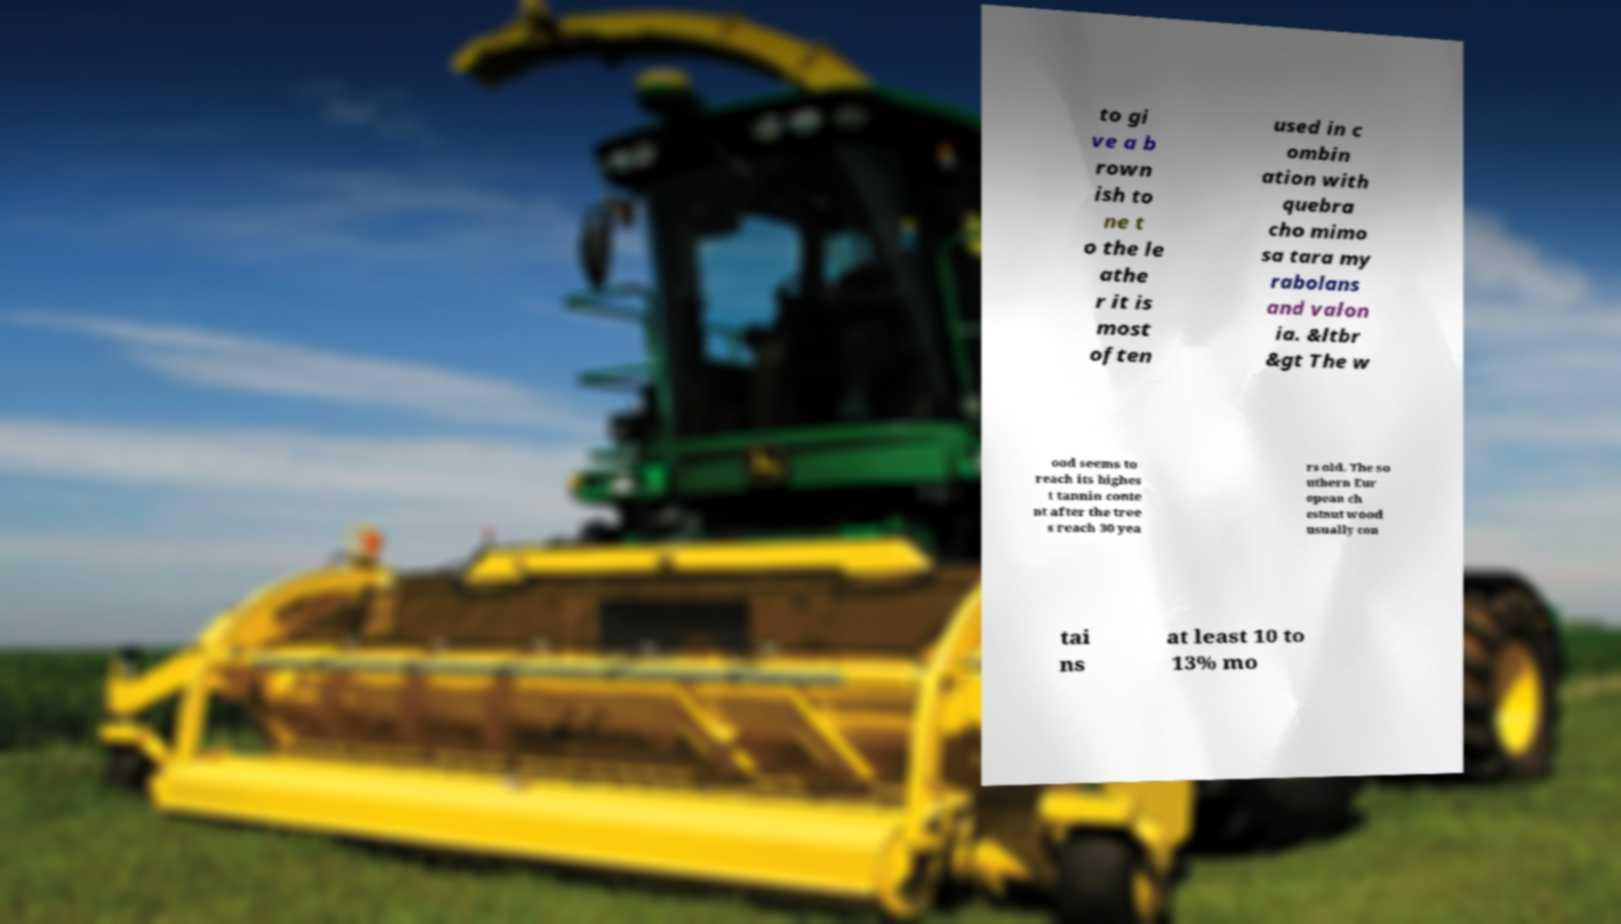Could you assist in decoding the text presented in this image and type it out clearly? to gi ve a b rown ish to ne t o the le athe r it is most often used in c ombin ation with quebra cho mimo sa tara my rabolans and valon ia. &ltbr &gt The w ood seems to reach its highes t tannin conte nt after the tree s reach 30 yea rs old. The so uthern Eur opean ch estnut wood usually con tai ns at least 10 to 13% mo 